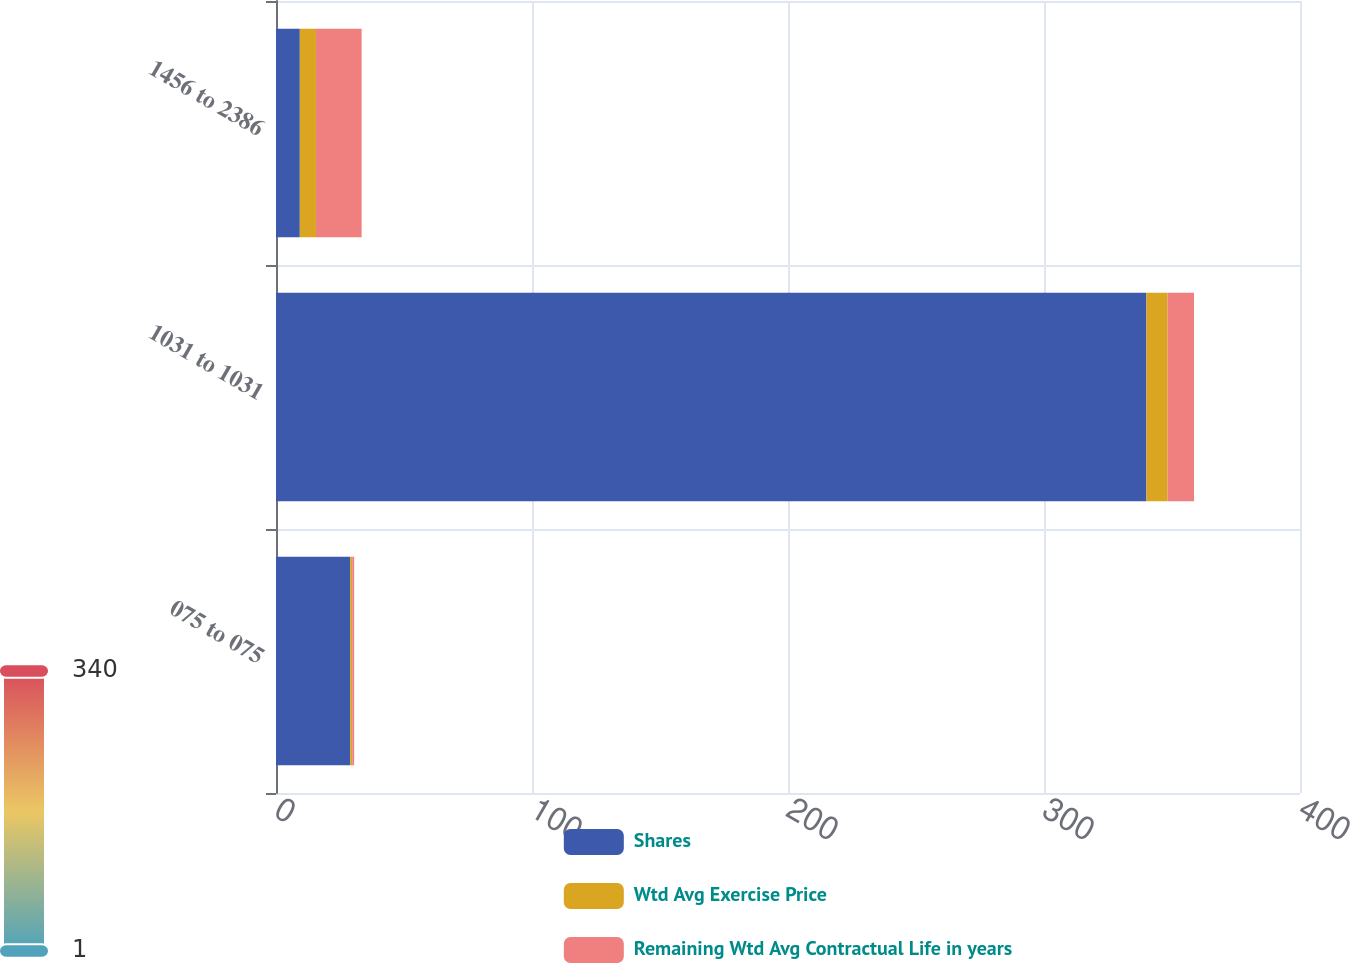Convert chart to OTSL. <chart><loc_0><loc_0><loc_500><loc_500><stacked_bar_chart><ecel><fcel>075 to 075<fcel>1031 to 1031<fcel>1456 to 2386<nl><fcel>Shares<fcel>29<fcel>340<fcel>9.3<nl><fcel>Wtd Avg Exercise Price<fcel>0.78<fcel>8.29<fcel>6.31<nl><fcel>Remaining Wtd Avg Contractual Life in years<fcel>0.75<fcel>10.31<fcel>17.84<nl></chart> 